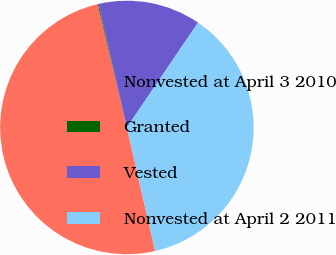Convert chart. <chart><loc_0><loc_0><loc_500><loc_500><pie_chart><fcel>Nonvested at April 3 2010<fcel>Granted<fcel>Vested<fcel>Nonvested at April 2 2011<nl><fcel>49.89%<fcel>0.11%<fcel>13.07%<fcel>36.93%<nl></chart> 